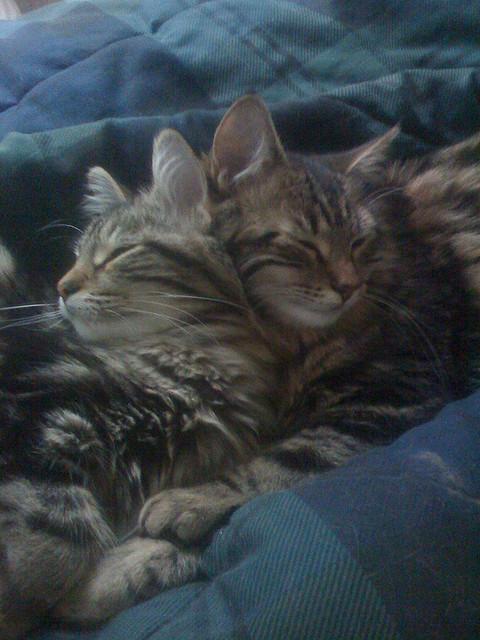How many cats are sleeping next to each other?
Give a very brief answer. 2. How many animals are shown?
Give a very brief answer. 2. How many cats are laying down?
Give a very brief answer. 2. How many cats are there?
Give a very brief answer. 2. How many people are in the picture?
Give a very brief answer. 0. 